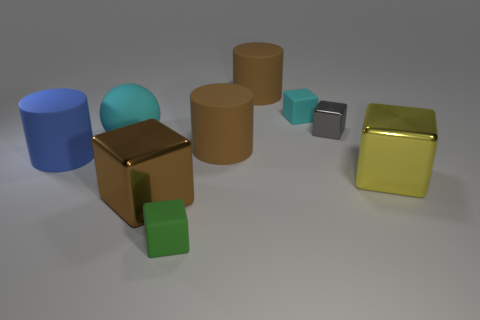There is a cyan object that is to the right of the brown thing behind the tiny object that is behind the gray thing; what is its size?
Offer a terse response. Small. There is a gray block that is the same size as the green rubber block; what is its material?
Offer a very short reply. Metal. Is there a purple shiny thing that has the same size as the green matte object?
Give a very brief answer. No. Is the size of the brown rubber object in front of the ball the same as the large blue object?
Your answer should be very brief. Yes. There is a large rubber thing that is in front of the big rubber ball and on the right side of the big matte sphere; what shape is it?
Provide a short and direct response. Cylinder. Is the number of green matte cubes that are right of the small green rubber object greater than the number of gray metallic objects?
Offer a terse response. No. What size is the gray block that is made of the same material as the yellow cube?
Your answer should be very brief. Small. How many big cylinders have the same color as the rubber sphere?
Provide a succinct answer. 0. Is the color of the tiny matte object on the right side of the small green thing the same as the rubber ball?
Provide a short and direct response. Yes. Is the number of tiny cubes that are right of the tiny cyan rubber thing the same as the number of large cyan things behind the tiny gray thing?
Provide a succinct answer. No. 